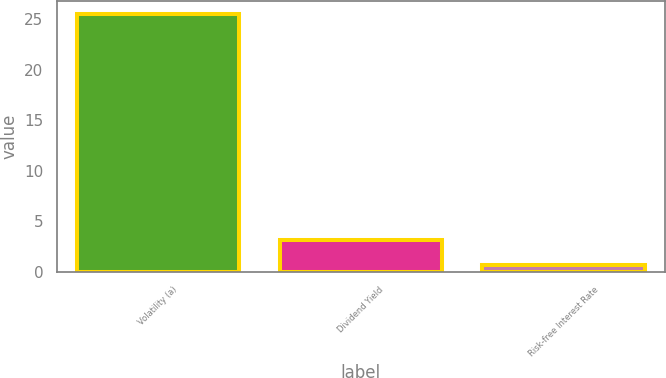Convert chart. <chart><loc_0><loc_0><loc_500><loc_500><bar_chart><fcel>Volatility (a)<fcel>Dividend Yield<fcel>Risk-free Interest Rate<nl><fcel>25.48<fcel>3.17<fcel>0.69<nl></chart> 